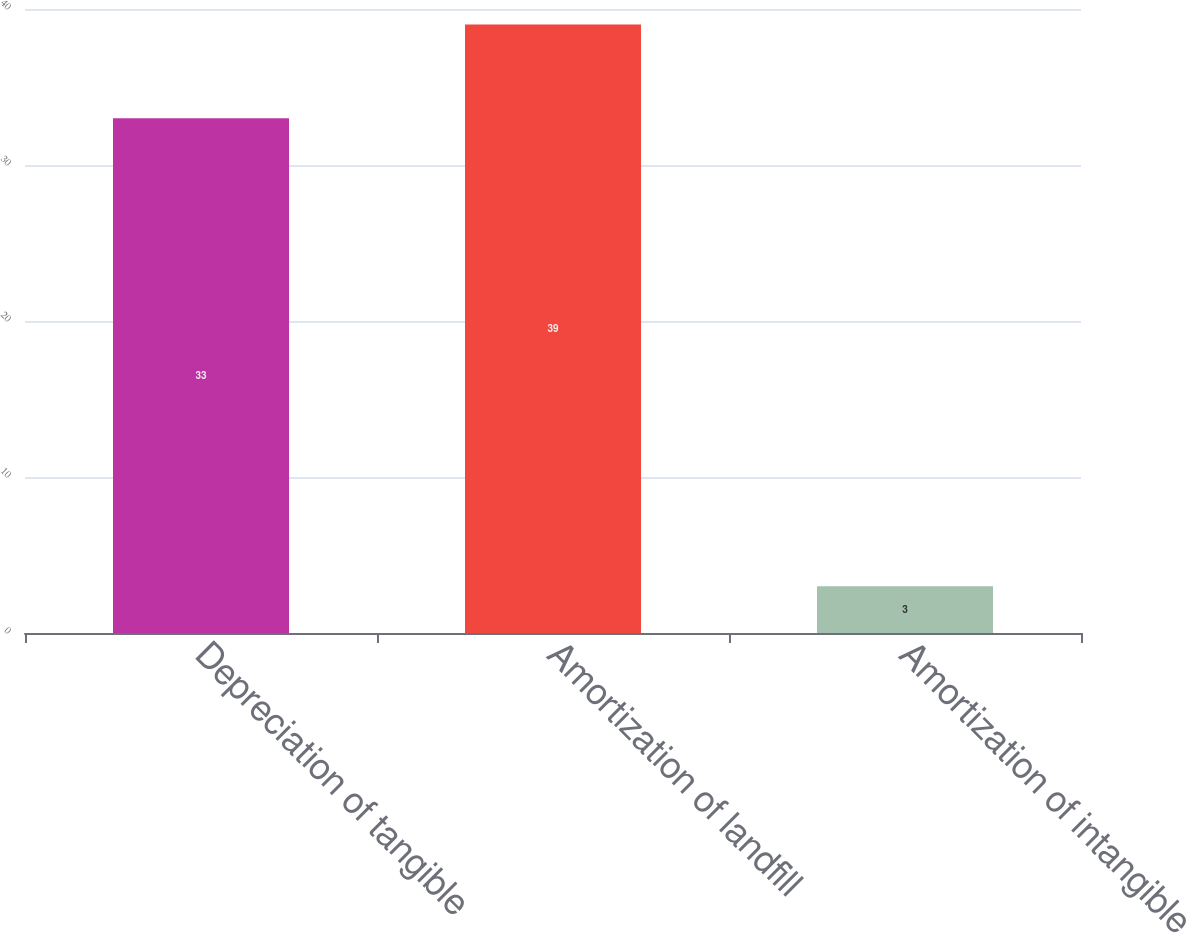Convert chart to OTSL. <chart><loc_0><loc_0><loc_500><loc_500><bar_chart><fcel>Depreciation of tangible<fcel>Amortization of landfill<fcel>Amortization of intangible<nl><fcel>33<fcel>39<fcel>3<nl></chart> 